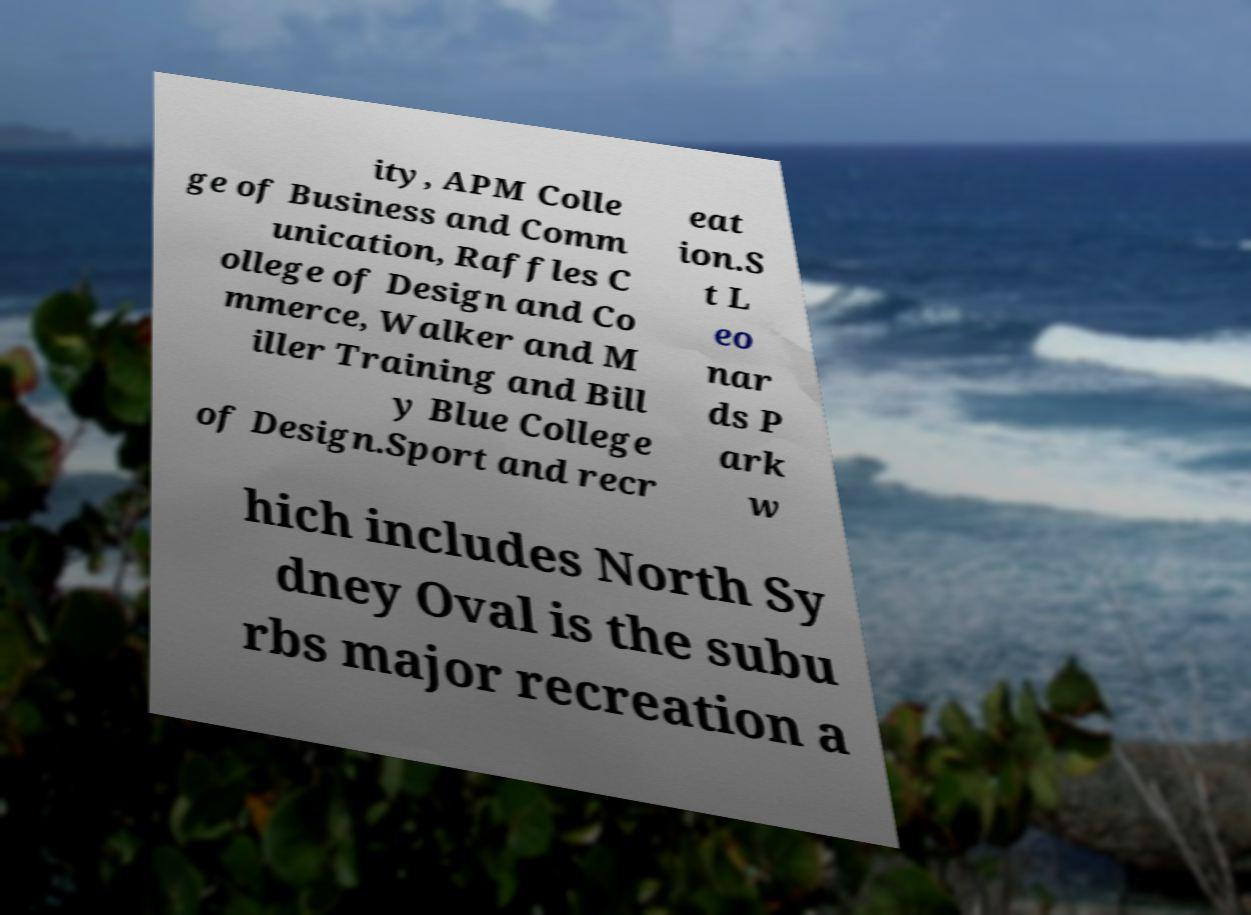Could you assist in decoding the text presented in this image and type it out clearly? ity, APM Colle ge of Business and Comm unication, Raffles C ollege of Design and Co mmerce, Walker and M iller Training and Bill y Blue College of Design.Sport and recr eat ion.S t L eo nar ds P ark w hich includes North Sy dney Oval is the subu rbs major recreation a 